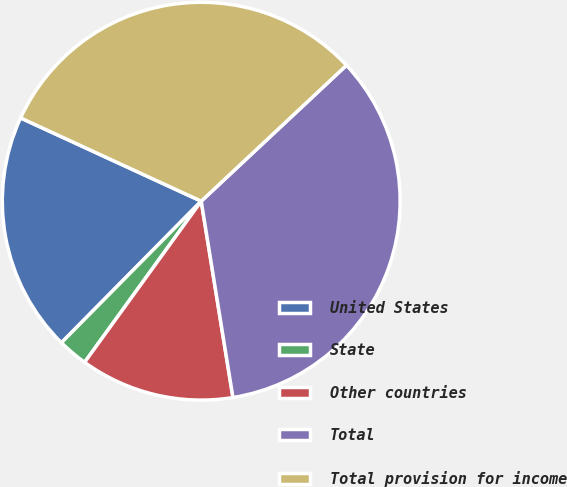<chart> <loc_0><loc_0><loc_500><loc_500><pie_chart><fcel>United States<fcel>State<fcel>Other countries<fcel>Total<fcel>Total provision for income<nl><fcel>19.47%<fcel>2.43%<fcel>12.52%<fcel>34.42%<fcel>31.15%<nl></chart> 